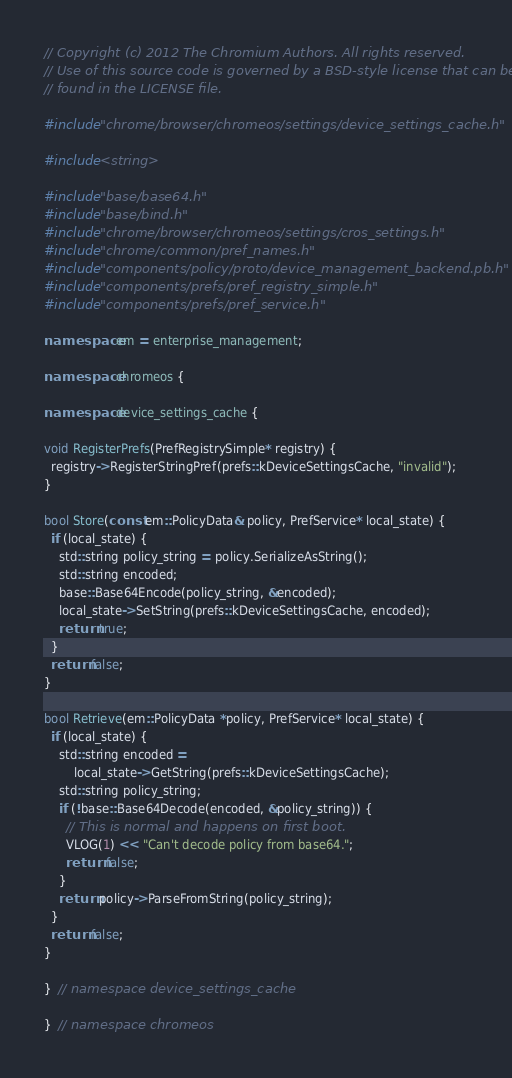Convert code to text. <code><loc_0><loc_0><loc_500><loc_500><_C++_>// Copyright (c) 2012 The Chromium Authors. All rights reserved.
// Use of this source code is governed by a BSD-style license that can be
// found in the LICENSE file.

#include "chrome/browser/chromeos/settings/device_settings_cache.h"

#include <string>

#include "base/base64.h"
#include "base/bind.h"
#include "chrome/browser/chromeos/settings/cros_settings.h"
#include "chrome/common/pref_names.h"
#include "components/policy/proto/device_management_backend.pb.h"
#include "components/prefs/pref_registry_simple.h"
#include "components/prefs/pref_service.h"

namespace em = enterprise_management;

namespace chromeos {

namespace device_settings_cache {

void RegisterPrefs(PrefRegistrySimple* registry) {
  registry->RegisterStringPref(prefs::kDeviceSettingsCache, "invalid");
}

bool Store(const em::PolicyData& policy, PrefService* local_state) {
  if (local_state) {
    std::string policy_string = policy.SerializeAsString();
    std::string encoded;
    base::Base64Encode(policy_string, &encoded);
    local_state->SetString(prefs::kDeviceSettingsCache, encoded);
    return true;
  }
  return false;
}

bool Retrieve(em::PolicyData *policy, PrefService* local_state) {
  if (local_state) {
    std::string encoded =
        local_state->GetString(prefs::kDeviceSettingsCache);
    std::string policy_string;
    if (!base::Base64Decode(encoded, &policy_string)) {
      // This is normal and happens on first boot.
      VLOG(1) << "Can't decode policy from base64.";
      return false;
    }
    return policy->ParseFromString(policy_string);
  }
  return false;
}

}  // namespace device_settings_cache

}  // namespace chromeos
</code> 